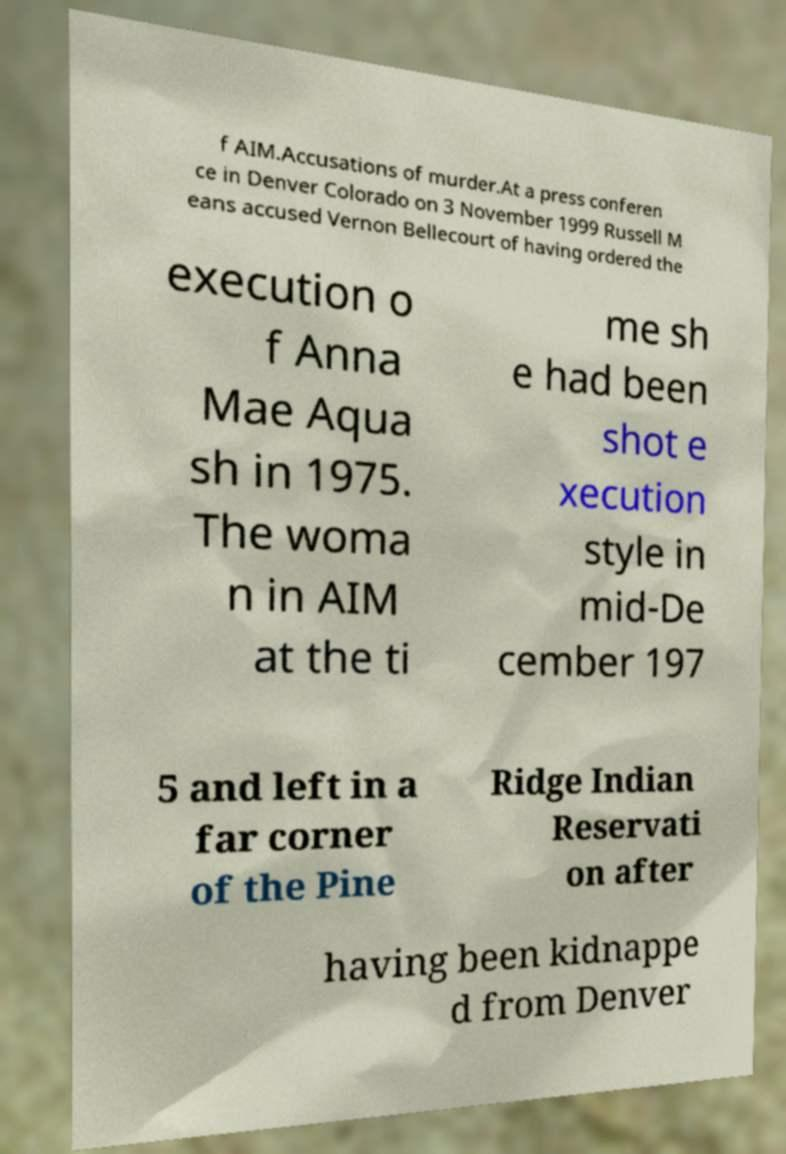Please read and relay the text visible in this image. What does it say? f AIM.Accusations of murder.At a press conferen ce in Denver Colorado on 3 November 1999 Russell M eans accused Vernon Bellecourt of having ordered the execution o f Anna Mae Aqua sh in 1975. The woma n in AIM at the ti me sh e had been shot e xecution style in mid-De cember 197 5 and left in a far corner of the Pine Ridge Indian Reservati on after having been kidnappe d from Denver 